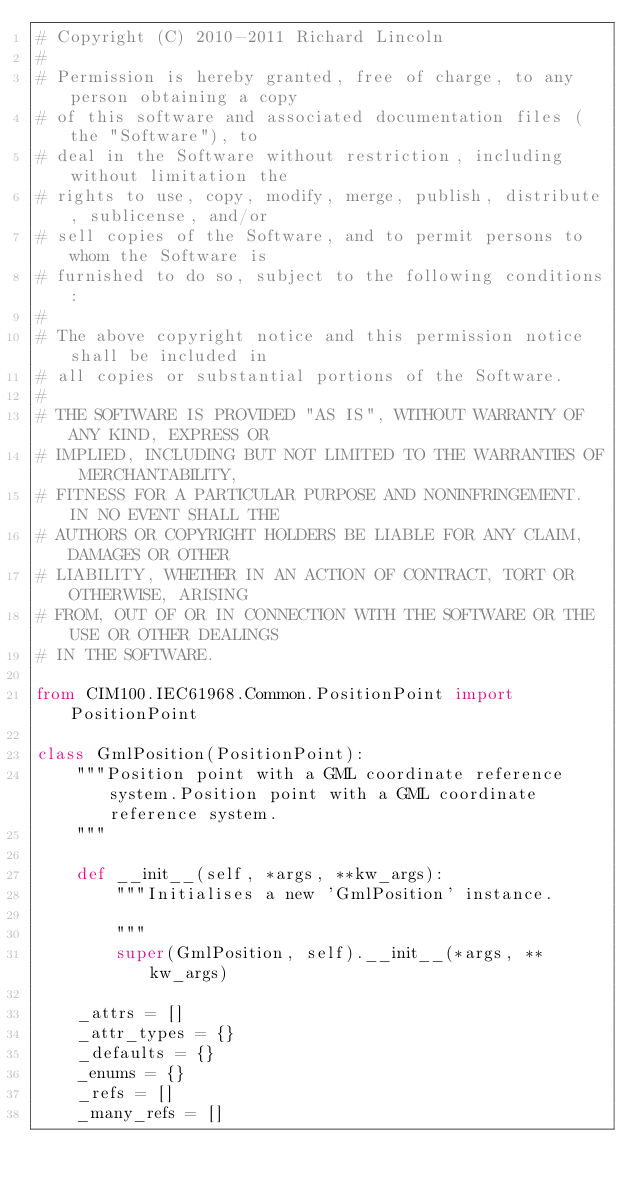Convert code to text. <code><loc_0><loc_0><loc_500><loc_500><_Python_># Copyright (C) 2010-2011 Richard Lincoln
#
# Permission is hereby granted, free of charge, to any person obtaining a copy
# of this software and associated documentation files (the "Software"), to
# deal in the Software without restriction, including without limitation the
# rights to use, copy, modify, merge, publish, distribute, sublicense, and/or
# sell copies of the Software, and to permit persons to whom the Software is
# furnished to do so, subject to the following conditions:
#
# The above copyright notice and this permission notice shall be included in
# all copies or substantial portions of the Software.
#
# THE SOFTWARE IS PROVIDED "AS IS", WITHOUT WARRANTY OF ANY KIND, EXPRESS OR
# IMPLIED, INCLUDING BUT NOT LIMITED TO THE WARRANTIES OF MERCHANTABILITY,
# FITNESS FOR A PARTICULAR PURPOSE AND NONINFRINGEMENT. IN NO EVENT SHALL THE
# AUTHORS OR COPYRIGHT HOLDERS BE LIABLE FOR ANY CLAIM, DAMAGES OR OTHER
# LIABILITY, WHETHER IN AN ACTION OF CONTRACT, TORT OR OTHERWISE, ARISING
# FROM, OUT OF OR IN CONNECTION WITH THE SOFTWARE OR THE USE OR OTHER DEALINGS
# IN THE SOFTWARE.

from CIM100.IEC61968.Common.PositionPoint import PositionPoint

class GmlPosition(PositionPoint):
    """Position point with a GML coordinate reference system.Position point with a GML coordinate reference system.
    """

    def __init__(self, *args, **kw_args):
        """Initialises a new 'GmlPosition' instance.

        """
        super(GmlPosition, self).__init__(*args, **kw_args)

    _attrs = []
    _attr_types = {}
    _defaults = {}
    _enums = {}
    _refs = []
    _many_refs = []

</code> 